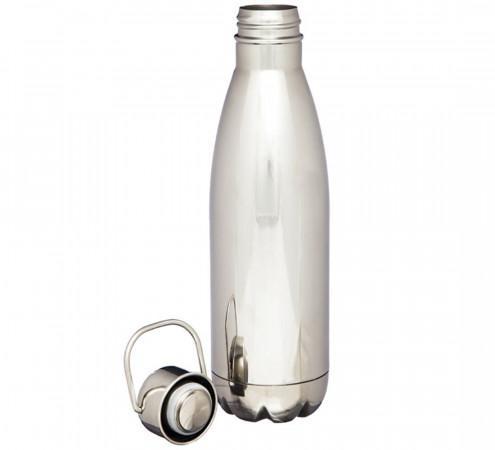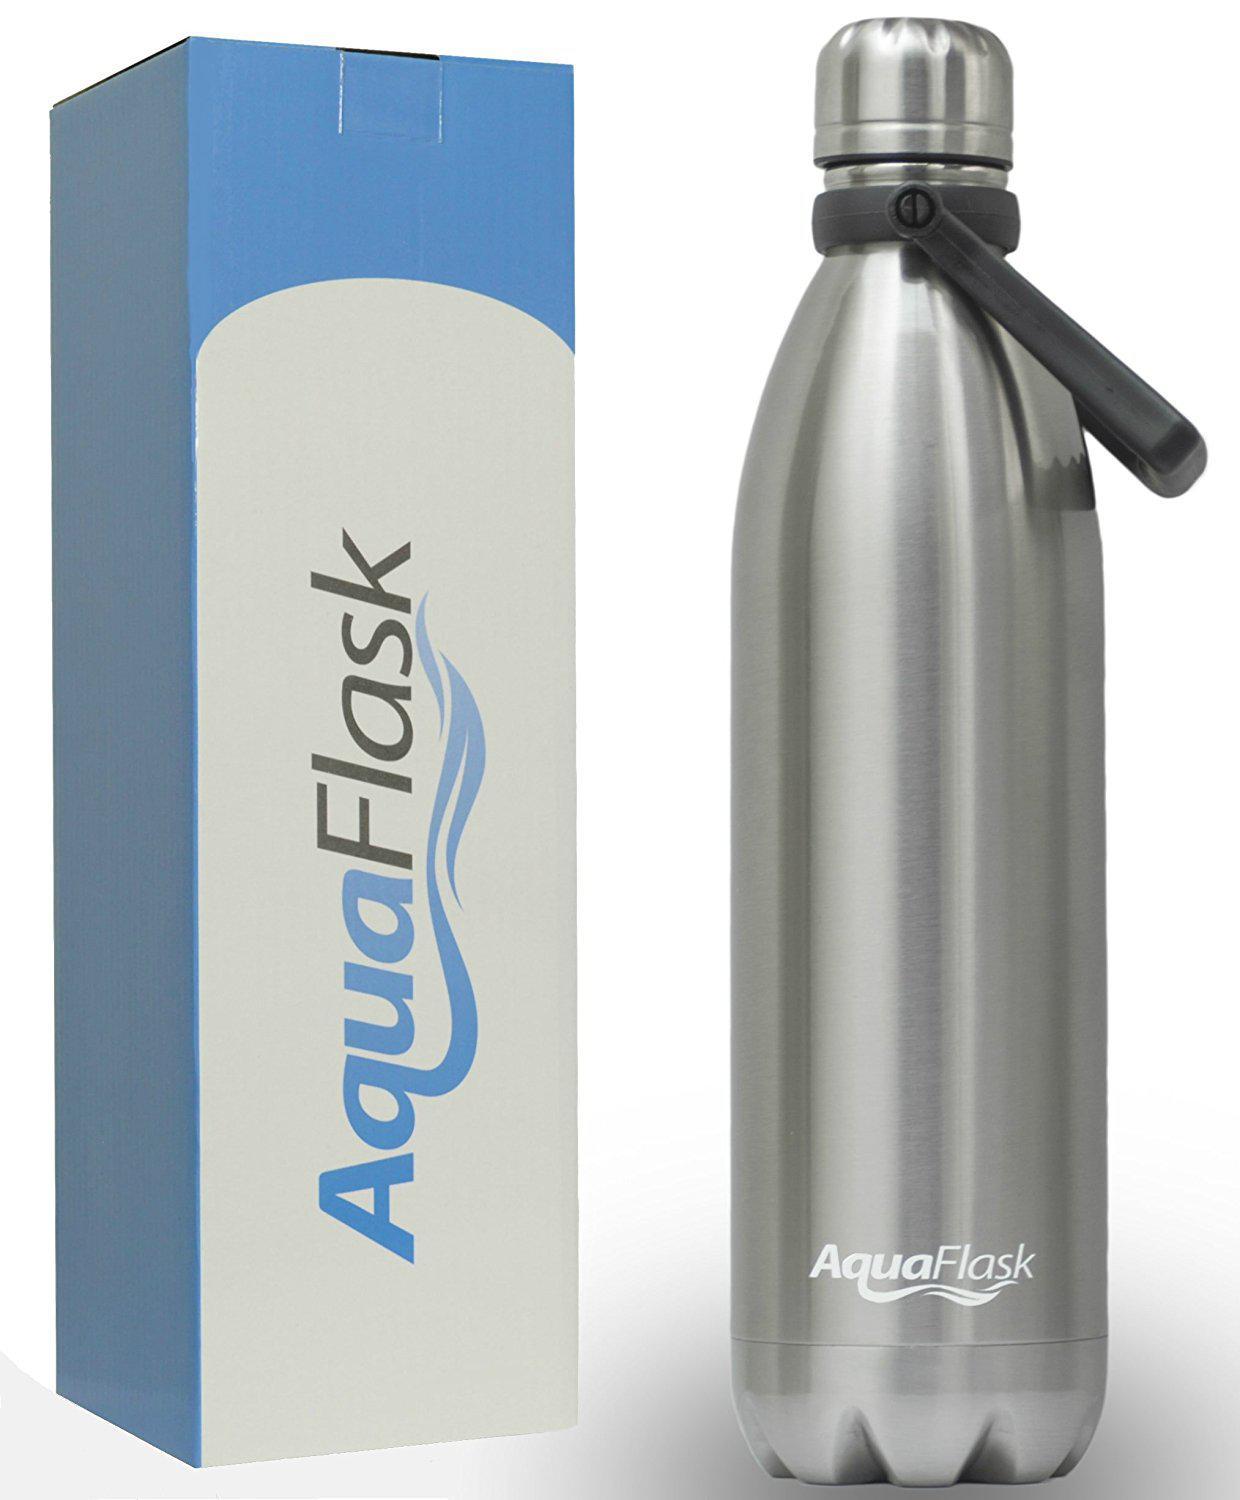The first image is the image on the left, the second image is the image on the right. Assess this claim about the two images: "The right and left images contain the same number of water bottles.". Correct or not? Answer yes or no. Yes. The first image is the image on the left, the second image is the image on the right. Analyze the images presented: Is the assertion "At least one of the containers is green in color." valid? Answer yes or no. No. 